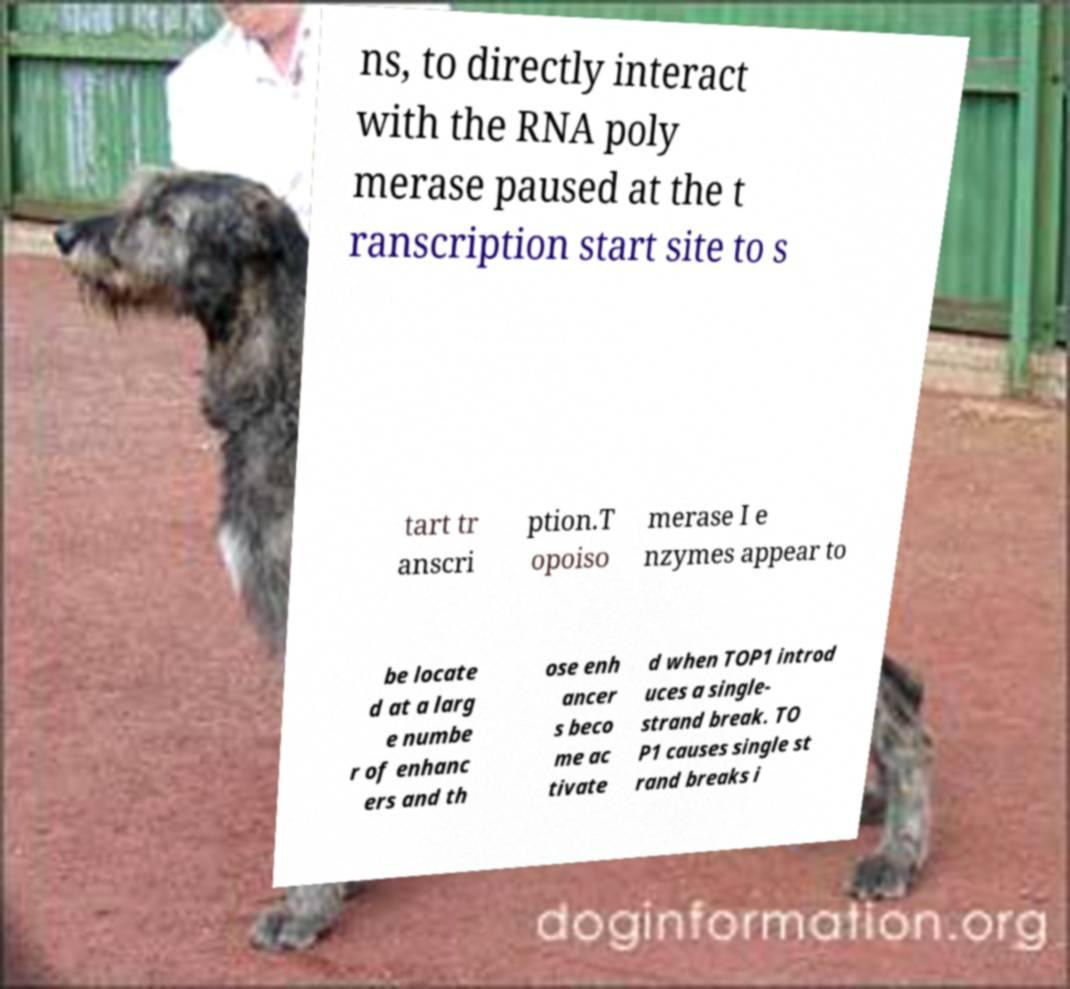For documentation purposes, I need the text within this image transcribed. Could you provide that? ns, to directly interact with the RNA poly merase paused at the t ranscription start site to s tart tr anscri ption.T opoiso merase I e nzymes appear to be locate d at a larg e numbe r of enhanc ers and th ose enh ancer s beco me ac tivate d when TOP1 introd uces a single- strand break. TO P1 causes single st rand breaks i 